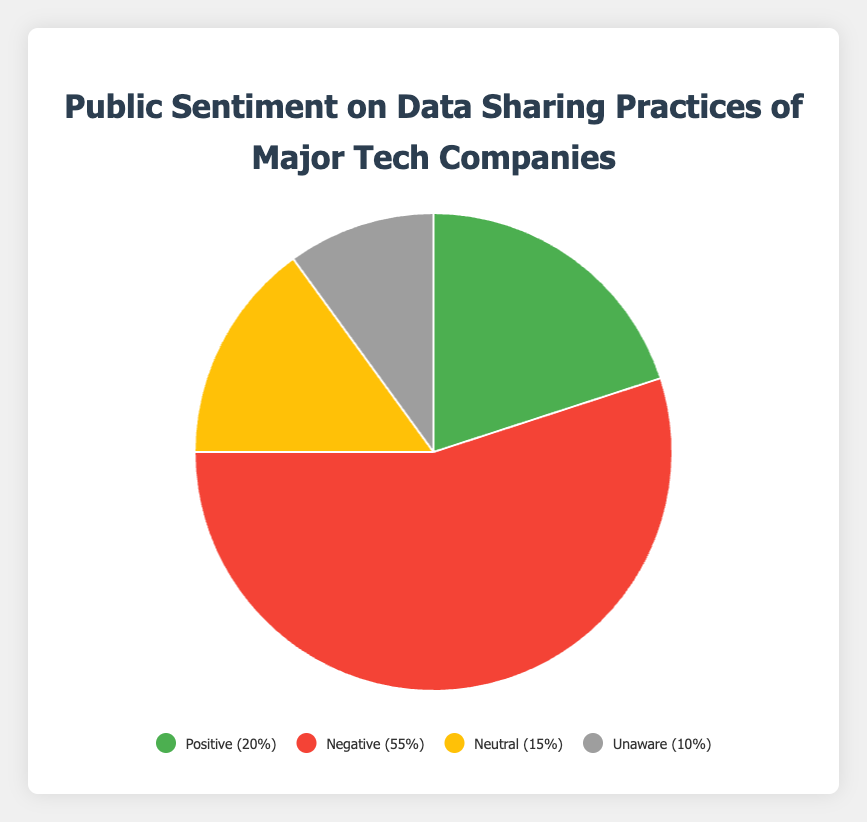What percentage of people are either Neutral or Unaware about data sharing practices? From the pie chart, we can see that Neutral is 15% and Unaware is 10%. Adding these two percentages: 15% + 10% = 25%.
Answer: 25% Which sentiment category has the highest percentage, and what is that percentage? The pie chart shows that the Negative sentiment category has the highest percentage at 55%.
Answer: Negative, 55% Is the percentage of people with Positive sentiment greater than those who are Neutral? From the pie chart, Positive sentiment is 20% and Neutral sentiment is 15%. 20% is greater than 15%.
Answer: Yes Which sentiment categories together have a larger percentage than Negative sentiment alone? Adding Positive (20%), Neutral (15%), and Unaware (10%) sentiment percentages: 20% + 15% + 10% = 45%, which is less than the Negative sentiment's 55%. So, none of the combinations are more significant than Negative alone.
Answer: None How much more is the Negative sentiment compared to the combined percentage of Positive and Neutral? The Negative sentiment is 55%, while the combined Positive and Neutral sentiment is 20% + 15% = 35%. The difference is 55% - 35% = 20%.
Answer: 20% What is the second highest sentiment category in terms of percentage? The pie chart indicates that the second highest sentiment category is Positive with 20%.
Answer: Positive How does the Unaware sentiment percentage compare to the combined percentage of Positive and Neutral sentiments? Unaware sentiment is at 10%, while the combined percentage of Positive and Neutral is 20% + 15% = 35%. 10% is less than 35%.
Answer: Less than 